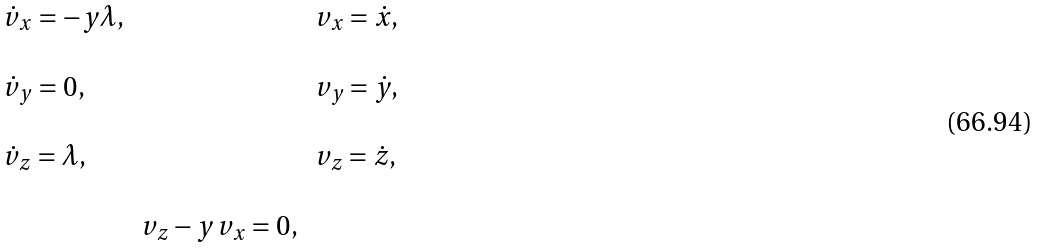<formula> <loc_0><loc_0><loc_500><loc_500>\begin{array} { l c l } \dot { v } _ { x } = - y \lambda , & & v _ { x } = \dot { x } , \\ \\ \dot { v } _ { y } = 0 , & & v _ { y } = \dot { y } , \\ \\ \dot { v } _ { z } = \lambda , & & v _ { z } = \dot { z } , \\ \\ & v _ { z } - y \, v _ { x } = 0 , & \end{array}</formula> 